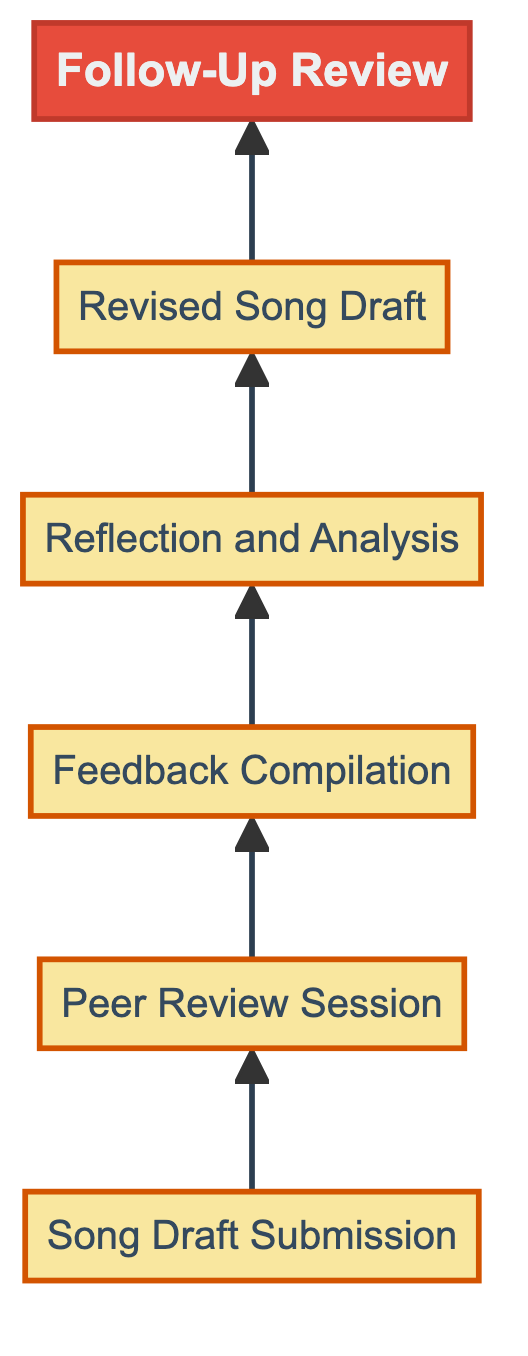What is the first step in the feedback loop? The first step is represented by the node labeled "Song Draft Submission," which indicates the submission of the initial song draft to peers for critique.
Answer: Song Draft Submission How many nodes are in the diagram? By counting the elements in the flowchart, we identify a total of six nodes that represent distinct stages in the feedback process.
Answer: 6 What follows after "Peer Review Session"? From the flowchart, the node that directly follows "Peer Review Session" is "Feedback Compilation," indicating the sequence in the feedback loop.
Answer: Feedback Compilation Which step involves gathering additional feedback? The step that involves gathering additional feedback is indicated by the node labeled "Follow-Up Review," which is the last step in the sequence.
Answer: Follow-Up Review In which step does the songwriter analyze feedback? Analysis of the feedback occurs in the step labeled "Reflection and Analysis," where the songwriter reviews and identifies themes in the comments received.
Answer: Reflection and Analysis Identify the relationship between "Feedback Compilation" and "Reflection and Analysis." "Feedback Compilation" leads into "Reflection and Analysis," showing a directional flow where compiled feedback is examined in the subsequent step.
Answer: Leads to What is the output of the "Revised Song Draft"? The output is the updated version of the song that incorporates the relevant feedback gathered from peers’ critiques in previous steps of the flowchart.
Answer: Revised Song Draft What color represents "Song Draft Submission"? The color assigned to "Song Draft Submission" in the diagram is a light blue shade, specifically coded as #aed6f1.
Answer: Light blue What is the last step before the Follow-Up Review? The step that comes immediately before "Follow-Up Review" in the flowchart is the revision process captured by the "Revised Song Draft."
Answer: Revised Song Draft Which node represents the songwriter's collaboration with peers? The flowchart node for collaboration with peers is "Peer Review Session," which encapsulates the activity of peers providing critiques of the song draft.
Answer: Peer Review Session 